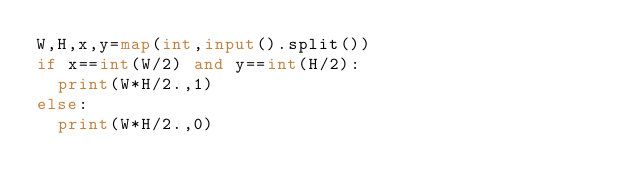<code> <loc_0><loc_0><loc_500><loc_500><_Python_>W,H,x,y=map(int,input().split())
if x==int(W/2) and y==int(H/2):
  print(W*H/2.,1)
else:
  print(W*H/2.,0)</code> 